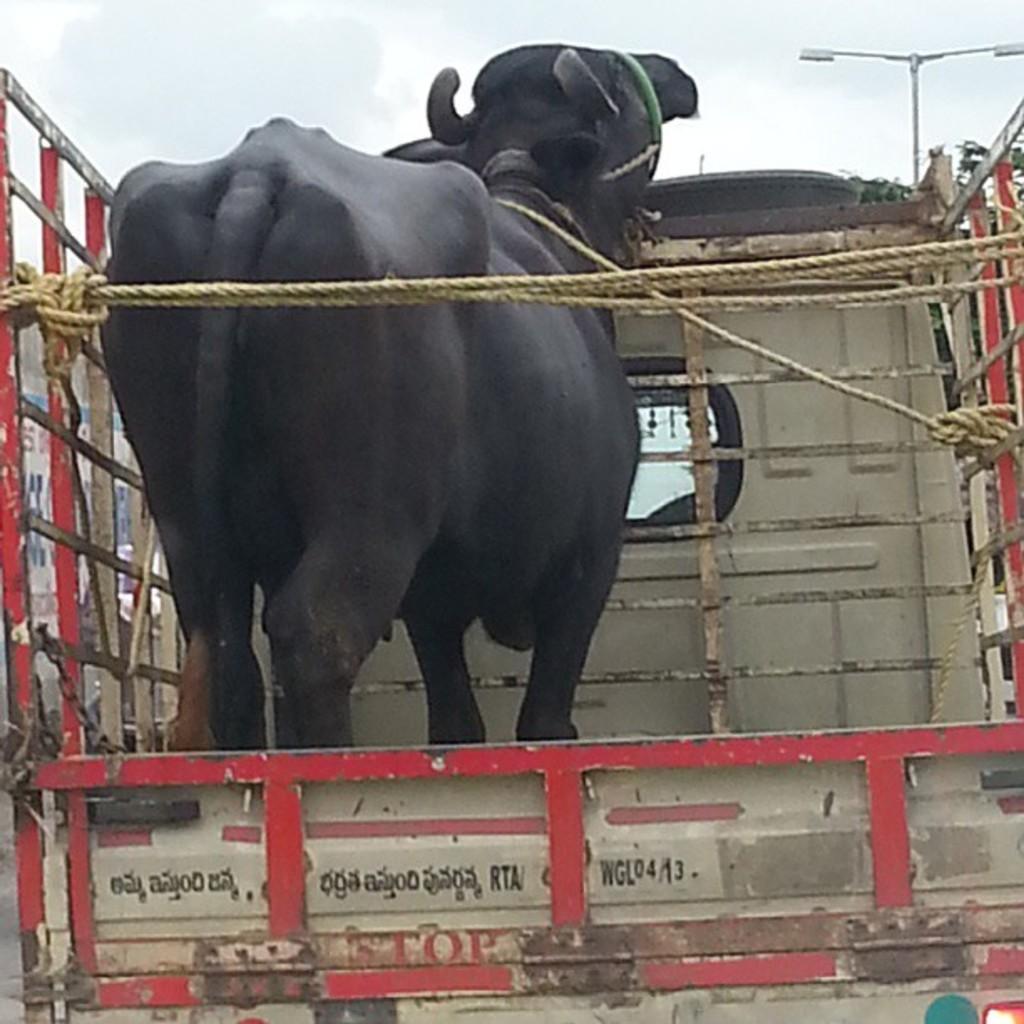Could you give a brief overview of what you see in this image? Here I can see a black color buffalo in a vehicle. In the background, I can see a street light. At the top I can see the sky. 